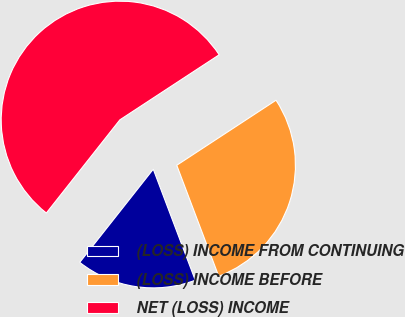<chart> <loc_0><loc_0><loc_500><loc_500><pie_chart><fcel>(LOSS) INCOME FROM CONTINUING<fcel>(LOSS) INCOME BEFORE<fcel>NET (LOSS) INCOME<nl><fcel>16.39%<fcel>28.48%<fcel>55.14%<nl></chart> 